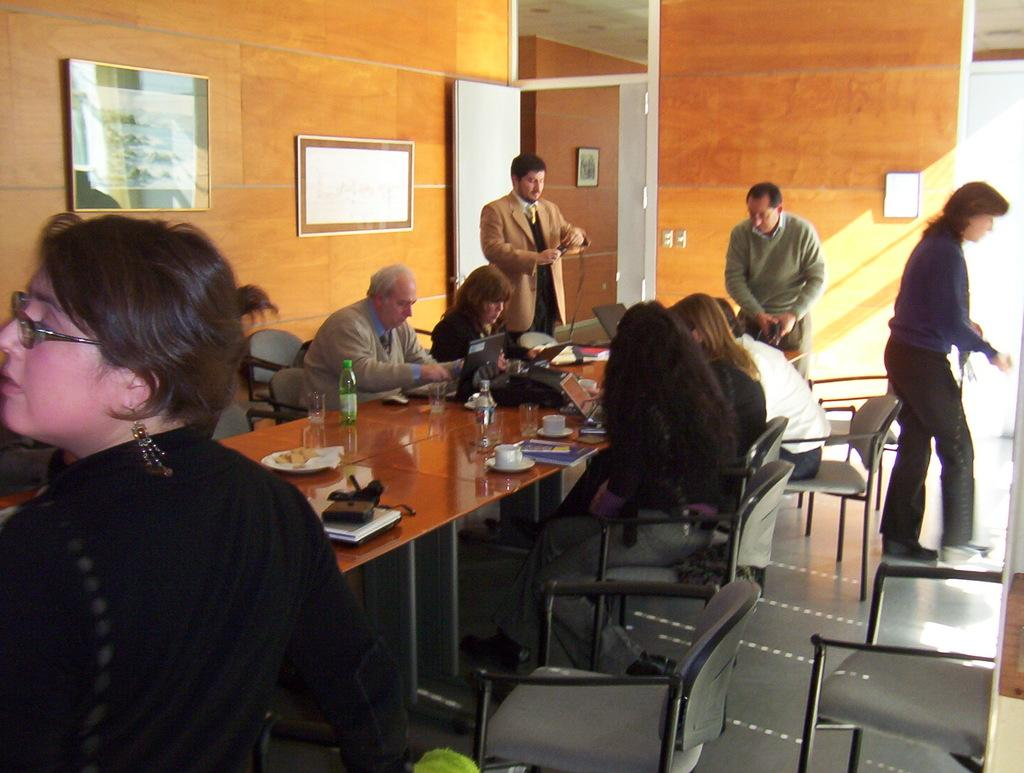What are the people in the image doing? There are people sitting on chairs and standing in the image. What objects can be seen on the table in the image? There are laptops on the table in the image. What type of structure can be seen in the background of the image? There is no structure visible in the background of the image. What toys are being used by the people in the image? There are no toys present in the image. 